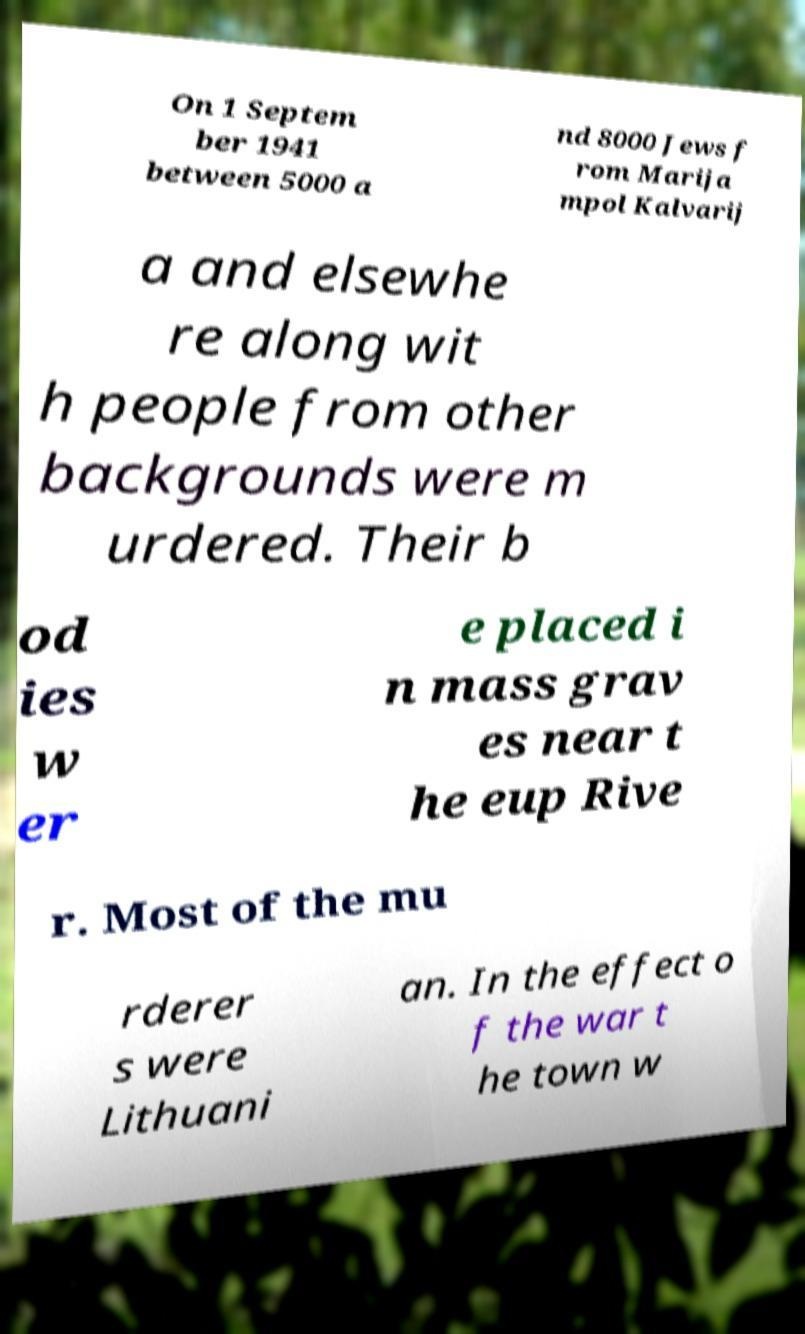Could you assist in decoding the text presented in this image and type it out clearly? On 1 Septem ber 1941 between 5000 a nd 8000 Jews f rom Marija mpol Kalvarij a and elsewhe re along wit h people from other backgrounds were m urdered. Their b od ies w er e placed i n mass grav es near t he eup Rive r. Most of the mu rderer s were Lithuani an. In the effect o f the war t he town w 